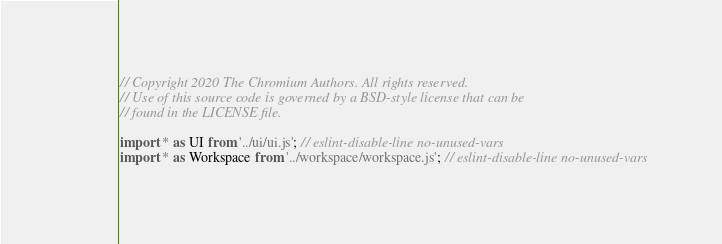Convert code to text. <code><loc_0><loc_0><loc_500><loc_500><_JavaScript_>// Copyright 2020 The Chromium Authors. All rights reserved.
// Use of this source code is governed by a BSD-style license that can be
// found in the LICENSE file.

import * as UI from '../ui/ui.js'; // eslint-disable-line no-unused-vars
import * as Workspace from '../workspace/workspace.js'; // eslint-disable-line no-unused-vars
</code> 